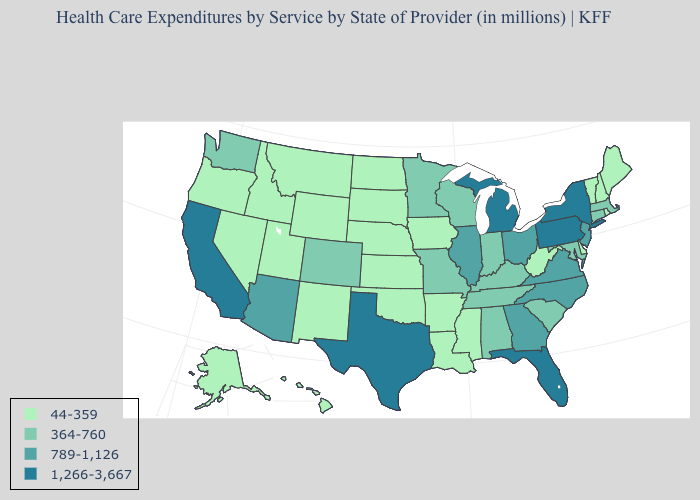Which states have the highest value in the USA?
Concise answer only. California, Florida, Michigan, New York, Pennsylvania, Texas. What is the value of Kentucky?
Quick response, please. 364-760. What is the value of Oregon?
Answer briefly. 44-359. Which states have the lowest value in the Northeast?
Write a very short answer. Maine, New Hampshire, Rhode Island, Vermont. Name the states that have a value in the range 1,266-3,667?
Answer briefly. California, Florida, Michigan, New York, Pennsylvania, Texas. Name the states that have a value in the range 789-1,126?
Short answer required. Arizona, Georgia, Illinois, New Jersey, North Carolina, Ohio, Virginia. Does Maryland have the highest value in the South?
Answer briefly. No. Which states have the lowest value in the USA?
Be succinct. Alaska, Arkansas, Delaware, Hawaii, Idaho, Iowa, Kansas, Louisiana, Maine, Mississippi, Montana, Nebraska, Nevada, New Hampshire, New Mexico, North Dakota, Oklahoma, Oregon, Rhode Island, South Dakota, Utah, Vermont, West Virginia, Wyoming. Name the states that have a value in the range 789-1,126?
Keep it brief. Arizona, Georgia, Illinois, New Jersey, North Carolina, Ohio, Virginia. What is the value of New Mexico?
Answer briefly. 44-359. How many symbols are there in the legend?
Give a very brief answer. 4. Name the states that have a value in the range 1,266-3,667?
Answer briefly. California, Florida, Michigan, New York, Pennsylvania, Texas. What is the value of New Mexico?
Concise answer only. 44-359. What is the value of Arizona?
Be succinct. 789-1,126. What is the value of Maryland?
Keep it brief. 364-760. 